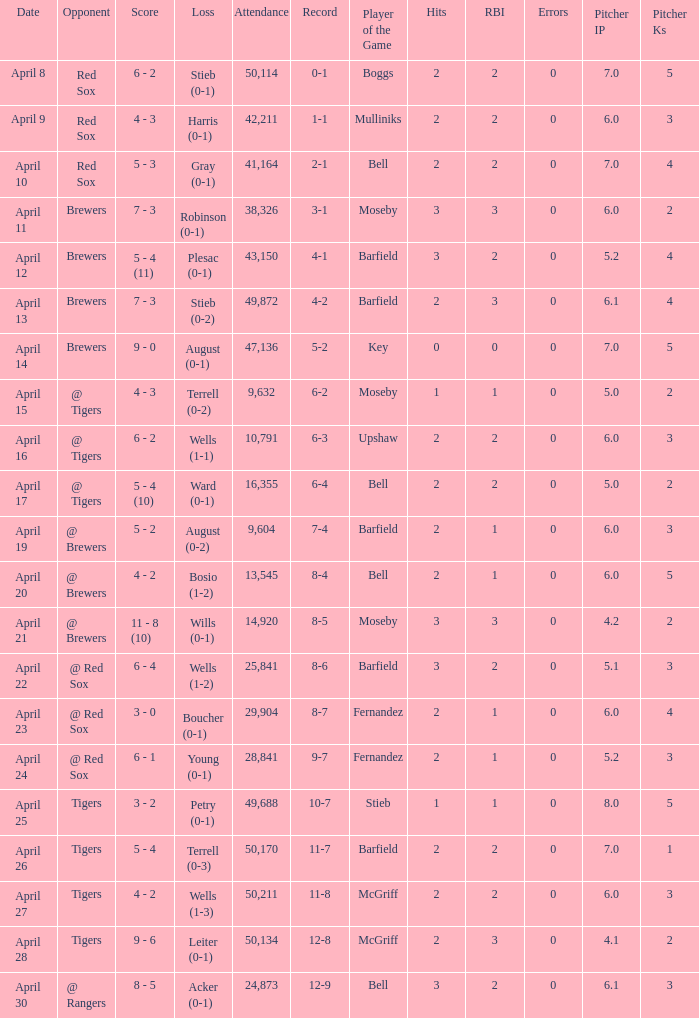What is the largest attendance that has tigers as the opponent and a loss of leiter (0-1)? 50134.0. Parse the full table. {'header': ['Date', 'Opponent', 'Score', 'Loss', 'Attendance', 'Record', 'Player of the Game', 'Hits', 'RBI', 'Errors', 'Pitcher IP', 'Pitcher Ks'], 'rows': [['April 8', 'Red Sox', '6 - 2', 'Stieb (0-1)', '50,114', '0-1', 'Boggs', '2', '2', '0', '7.0', '5'], ['April 9', 'Red Sox', '4 - 3', 'Harris (0-1)', '42,211', '1-1', 'Mulliniks', '2', '2', '0', '6.0', '3'], ['April 10', 'Red Sox', '5 - 3', 'Gray (0-1)', '41,164', '2-1', 'Bell', '2', '2', '0', '7.0', '4'], ['April 11', 'Brewers', '7 - 3', 'Robinson (0-1)', '38,326', '3-1', 'Moseby', '3', '3', '0', '6.0', '2'], ['April 12', 'Brewers', '5 - 4 (11)', 'Plesac (0-1)', '43,150', '4-1', 'Barfield', '3', '2', '0', '5.2', '4'], ['April 13', 'Brewers', '7 - 3', 'Stieb (0-2)', '49,872', '4-2', 'Barfield', '2', '3', '0', '6.1', '4'], ['April 14', 'Brewers', '9 - 0', 'August (0-1)', '47,136', '5-2', 'Key', '0', '0', '0', '7.0', '5'], ['April 15', '@ Tigers', '4 - 3', 'Terrell (0-2)', '9,632', '6-2', 'Moseby', '1', '1', '0', '5.0', '2'], ['April 16', '@ Tigers', '6 - 2', 'Wells (1-1)', '10,791', '6-3', 'Upshaw', '2', '2', '0', '6.0', '3'], ['April 17', '@ Tigers', '5 - 4 (10)', 'Ward (0-1)', '16,355', '6-4', 'Bell', '2', '2', '0', '5.0', '2'], ['April 19', '@ Brewers', '5 - 2', 'August (0-2)', '9,604', '7-4', 'Barfield', '2', '1', '0', '6.0', '3'], ['April 20', '@ Brewers', '4 - 2', 'Bosio (1-2)', '13,545', '8-4', 'Bell', '2', '1', '0', '6.0', '5'], ['April 21', '@ Brewers', '11 - 8 (10)', 'Wills (0-1)', '14,920', '8-5', 'Moseby', '3', '3', '0', '4.2', '2'], ['April 22', '@ Red Sox', '6 - 4', 'Wells (1-2)', '25,841', '8-6', 'Barfield', '3', '2', '0', '5.1', '3'], ['April 23', '@ Red Sox', '3 - 0', 'Boucher (0-1)', '29,904', '8-7', 'Fernandez', '2', '1', '0', '6.0', '4'], ['April 24', '@ Red Sox', '6 - 1', 'Young (0-1)', '28,841', '9-7', 'Fernandez', '2', '1', '0', '5.2', '3'], ['April 25', 'Tigers', '3 - 2', 'Petry (0-1)', '49,688', '10-7', 'Stieb', '1', '1', '0', '8.0', '5'], ['April 26', 'Tigers', '5 - 4', 'Terrell (0-3)', '50,170', '11-7', 'Barfield', '2', '2', '0', '7.0', '1'], ['April 27', 'Tigers', '4 - 2', 'Wells (1-3)', '50,211', '11-8', 'McGriff', '2', '2', '0', '6.0', '3'], ['April 28', 'Tigers', '9 - 6', 'Leiter (0-1)', '50,134', '12-8', 'McGriff', '2', '3', '0', '4.1', '2'], ['April 30', '@ Rangers', '8 - 5', 'Acker (0-1)', '24,873', '12-9', 'Bell', '3', '2', '0', '6.1', '3']]} 